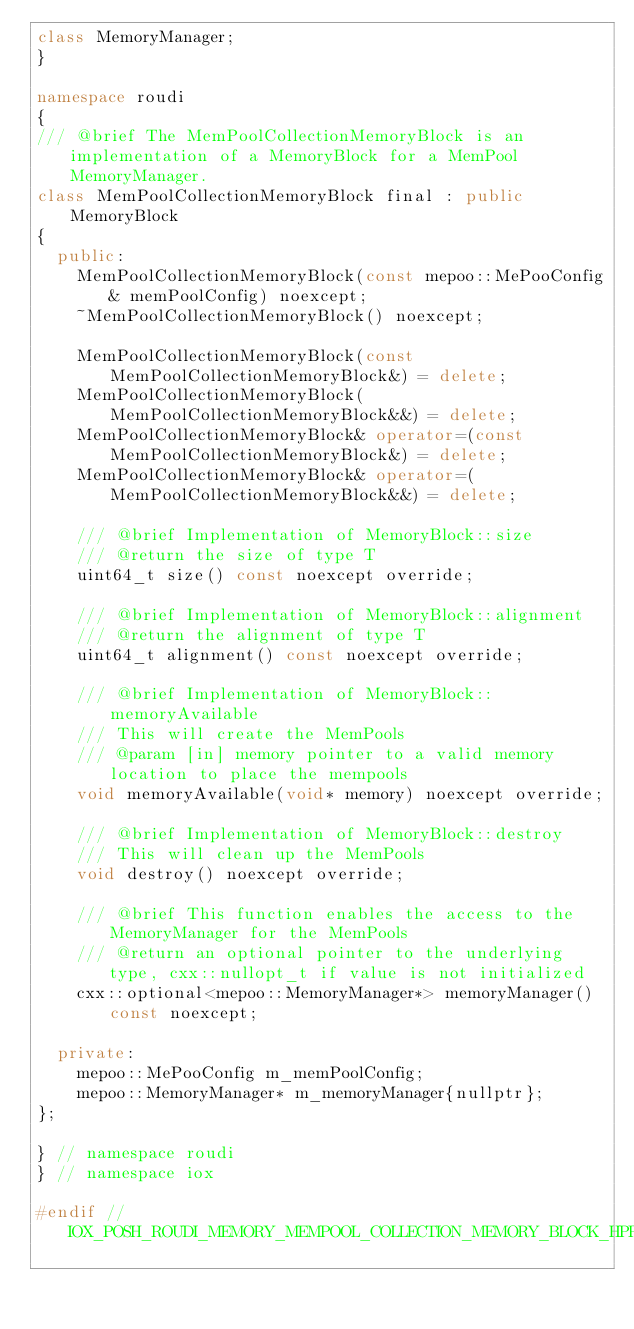<code> <loc_0><loc_0><loc_500><loc_500><_C++_>class MemoryManager;
}

namespace roudi
{
/// @brief The MemPoolCollectionMemoryBlock is an implementation of a MemoryBlock for a MemPool MemoryManager.
class MemPoolCollectionMemoryBlock final : public MemoryBlock
{
  public:
    MemPoolCollectionMemoryBlock(const mepoo::MePooConfig& memPoolConfig) noexcept;
    ~MemPoolCollectionMemoryBlock() noexcept;

    MemPoolCollectionMemoryBlock(const MemPoolCollectionMemoryBlock&) = delete;
    MemPoolCollectionMemoryBlock(MemPoolCollectionMemoryBlock&&) = delete;
    MemPoolCollectionMemoryBlock& operator=(const MemPoolCollectionMemoryBlock&) = delete;
    MemPoolCollectionMemoryBlock& operator=(MemPoolCollectionMemoryBlock&&) = delete;

    /// @brief Implementation of MemoryBlock::size
    /// @return the size of type T
    uint64_t size() const noexcept override;

    /// @brief Implementation of MemoryBlock::alignment
    /// @return the alignment of type T
    uint64_t alignment() const noexcept override;

    /// @brief Implementation of MemoryBlock::memoryAvailable
    /// This will create the MemPools
    /// @param [in] memory pointer to a valid memory location to place the mempools
    void memoryAvailable(void* memory) noexcept override;

    /// @brief Implementation of MemoryBlock::destroy
    /// This will clean up the MemPools
    void destroy() noexcept override;

    /// @brief This function enables the access to the MemoryManager for the MemPools
    /// @return an optional pointer to the underlying type, cxx::nullopt_t if value is not initialized
    cxx::optional<mepoo::MemoryManager*> memoryManager() const noexcept;

  private:
    mepoo::MePooConfig m_memPoolConfig;
    mepoo::MemoryManager* m_memoryManager{nullptr};
};

} // namespace roudi
} // namespace iox

#endif // IOX_POSH_ROUDI_MEMORY_MEMPOOL_COLLECTION_MEMORY_BLOCK_HPP
</code> 